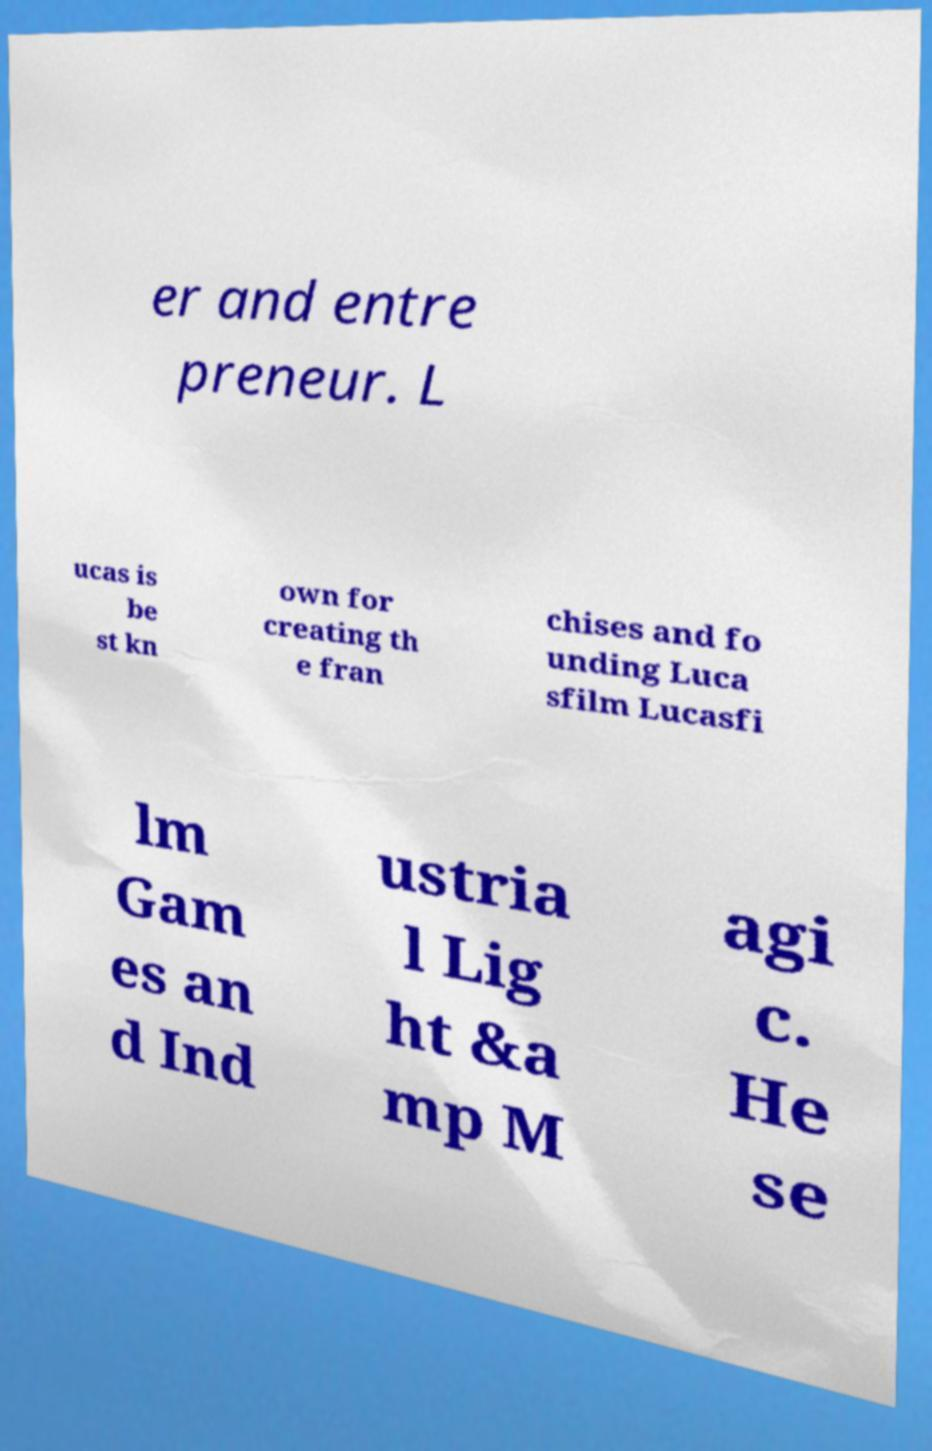Could you extract and type out the text from this image? er and entre preneur. L ucas is be st kn own for creating th e fran chises and fo unding Luca sfilm Lucasfi lm Gam es an d Ind ustria l Lig ht &a mp M agi c. He se 